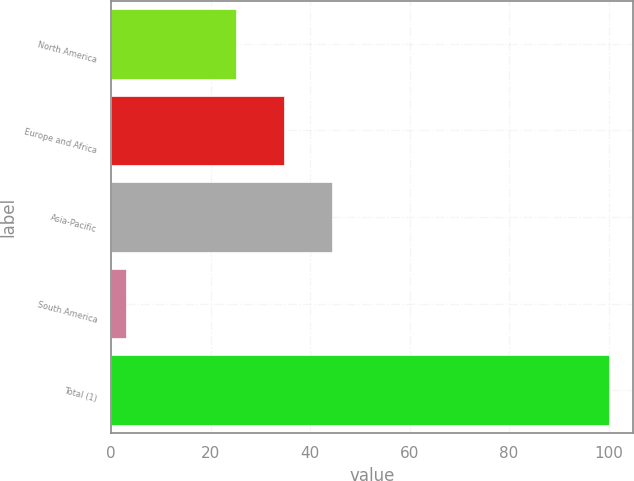Convert chart to OTSL. <chart><loc_0><loc_0><loc_500><loc_500><bar_chart><fcel>North America<fcel>Europe and Africa<fcel>Asia-Pacific<fcel>South America<fcel>Total (1)<nl><fcel>25<fcel>34.7<fcel>44.4<fcel>3<fcel>100<nl></chart> 